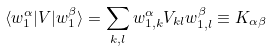<formula> <loc_0><loc_0><loc_500><loc_500>\langle w _ { 1 } ^ { \alpha } | V | w _ { 1 } ^ { \beta } \rangle = \sum _ { k , l } w _ { 1 , k } ^ { \alpha } V _ { k l } w _ { 1 , l } ^ { \beta } \equiv K _ { \alpha \beta }</formula> 